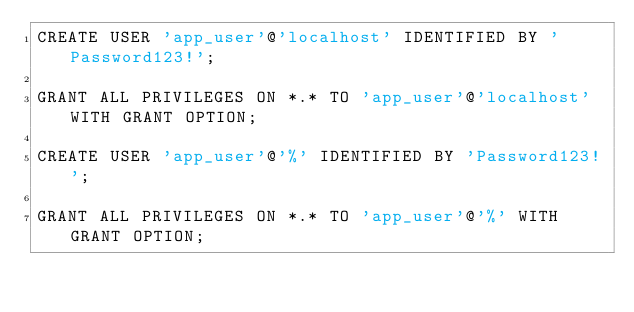Convert code to text. <code><loc_0><loc_0><loc_500><loc_500><_SQL_>CREATE USER 'app_user'@'localhost' IDENTIFIED BY 'Password123!';

GRANT ALL PRIVILEGES ON *.* TO 'app_user'@'localhost' WITH GRANT OPTION;

CREATE USER 'app_user'@'%' IDENTIFIED BY 'Password123!';

GRANT ALL PRIVILEGES ON *.* TO 'app_user'@'%' WITH GRANT OPTION;</code> 